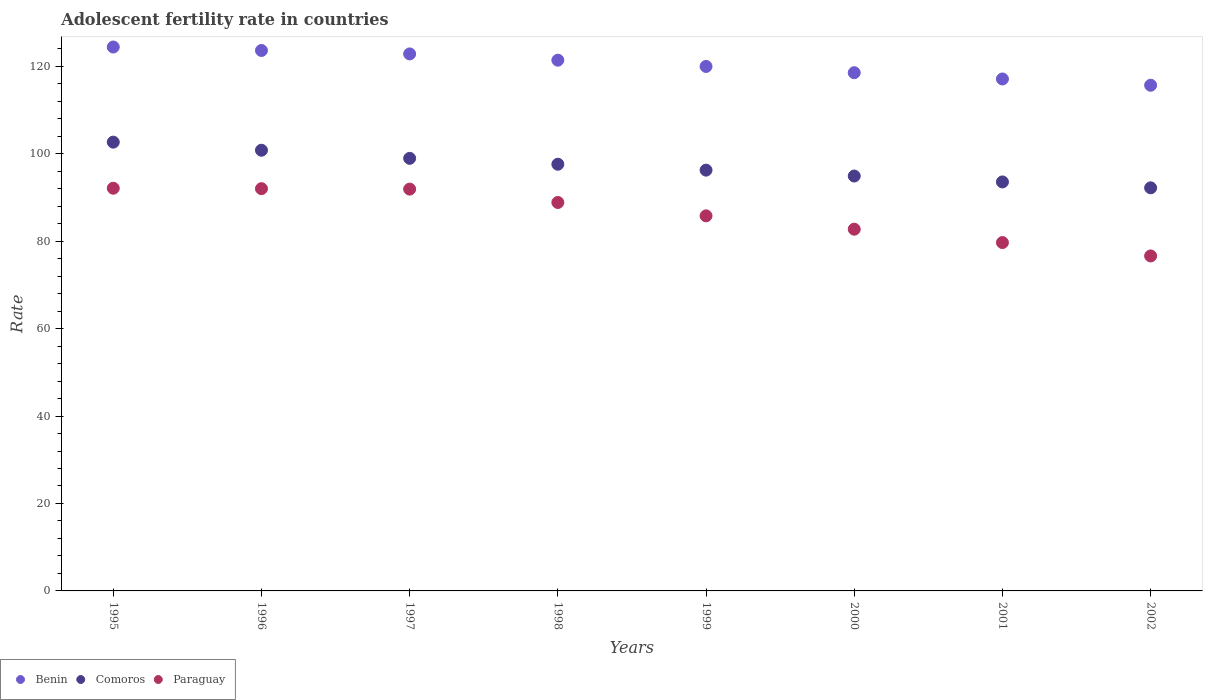How many different coloured dotlines are there?
Provide a short and direct response. 3. Is the number of dotlines equal to the number of legend labels?
Provide a short and direct response. Yes. What is the adolescent fertility rate in Paraguay in 1998?
Keep it short and to the point. 88.85. Across all years, what is the maximum adolescent fertility rate in Paraguay?
Offer a terse response. 92.1. Across all years, what is the minimum adolescent fertility rate in Comoros?
Make the answer very short. 92.19. In which year was the adolescent fertility rate in Benin maximum?
Your answer should be compact. 1995. What is the total adolescent fertility rate in Paraguay in the graph?
Your answer should be compact. 689.67. What is the difference between the adolescent fertility rate in Paraguay in 1999 and that in 2000?
Your answer should be compact. 3.06. What is the difference between the adolescent fertility rate in Paraguay in 1997 and the adolescent fertility rate in Comoros in 1999?
Offer a very short reply. -4.34. What is the average adolescent fertility rate in Comoros per year?
Provide a short and direct response. 97.11. In the year 2001, what is the difference between the adolescent fertility rate in Benin and adolescent fertility rate in Comoros?
Ensure brevity in your answer.  23.55. What is the ratio of the adolescent fertility rate in Paraguay in 1995 to that in 1997?
Ensure brevity in your answer.  1. Is the adolescent fertility rate in Benin in 1995 less than that in 1997?
Provide a succinct answer. No. What is the difference between the highest and the second highest adolescent fertility rate in Benin?
Your response must be concise. 0.79. What is the difference between the highest and the lowest adolescent fertility rate in Comoros?
Your answer should be compact. 10.45. Is the sum of the adolescent fertility rate in Benin in 1996 and 2000 greater than the maximum adolescent fertility rate in Comoros across all years?
Keep it short and to the point. Yes. Is it the case that in every year, the sum of the adolescent fertility rate in Comoros and adolescent fertility rate in Benin  is greater than the adolescent fertility rate in Paraguay?
Give a very brief answer. Yes. Does the adolescent fertility rate in Paraguay monotonically increase over the years?
Your answer should be compact. No. Is the adolescent fertility rate in Comoros strictly less than the adolescent fertility rate in Benin over the years?
Ensure brevity in your answer.  Yes. How many years are there in the graph?
Your response must be concise. 8. What is the difference between two consecutive major ticks on the Y-axis?
Keep it short and to the point. 20. Does the graph contain grids?
Offer a very short reply. No. Where does the legend appear in the graph?
Your response must be concise. Bottom left. How are the legend labels stacked?
Give a very brief answer. Horizontal. What is the title of the graph?
Keep it short and to the point. Adolescent fertility rate in countries. Does "Solomon Islands" appear as one of the legend labels in the graph?
Your response must be concise. No. What is the label or title of the Y-axis?
Provide a succinct answer. Rate. What is the Rate in Benin in 1995?
Your answer should be very brief. 124.4. What is the Rate in Comoros in 1995?
Provide a short and direct response. 102.64. What is the Rate of Paraguay in 1995?
Give a very brief answer. 92.1. What is the Rate of Benin in 1996?
Give a very brief answer. 123.61. What is the Rate of Comoros in 1996?
Keep it short and to the point. 100.79. What is the Rate in Paraguay in 1996?
Provide a succinct answer. 92. What is the Rate of Benin in 1997?
Ensure brevity in your answer.  122.82. What is the Rate in Comoros in 1997?
Your answer should be very brief. 98.94. What is the Rate of Paraguay in 1997?
Your answer should be compact. 91.9. What is the Rate in Benin in 1998?
Your answer should be compact. 121.39. What is the Rate of Comoros in 1998?
Offer a very short reply. 97.59. What is the Rate of Paraguay in 1998?
Your response must be concise. 88.85. What is the Rate of Benin in 1999?
Give a very brief answer. 119.96. What is the Rate in Comoros in 1999?
Your response must be concise. 96.24. What is the Rate in Paraguay in 1999?
Your answer should be very brief. 85.79. What is the Rate of Benin in 2000?
Offer a very short reply. 118.52. What is the Rate in Comoros in 2000?
Your answer should be very brief. 94.89. What is the Rate in Paraguay in 2000?
Your response must be concise. 82.73. What is the Rate in Benin in 2001?
Offer a terse response. 117.09. What is the Rate in Comoros in 2001?
Provide a succinct answer. 93.54. What is the Rate in Paraguay in 2001?
Your response must be concise. 79.68. What is the Rate of Benin in 2002?
Give a very brief answer. 115.66. What is the Rate in Comoros in 2002?
Offer a terse response. 92.19. What is the Rate of Paraguay in 2002?
Your answer should be compact. 76.62. Across all years, what is the maximum Rate in Benin?
Your response must be concise. 124.4. Across all years, what is the maximum Rate of Comoros?
Make the answer very short. 102.64. Across all years, what is the maximum Rate in Paraguay?
Provide a short and direct response. 92.1. Across all years, what is the minimum Rate in Benin?
Give a very brief answer. 115.66. Across all years, what is the minimum Rate of Comoros?
Ensure brevity in your answer.  92.19. Across all years, what is the minimum Rate in Paraguay?
Ensure brevity in your answer.  76.62. What is the total Rate of Benin in the graph?
Your response must be concise. 963.46. What is the total Rate of Comoros in the graph?
Your response must be concise. 776.85. What is the total Rate in Paraguay in the graph?
Make the answer very short. 689.67. What is the difference between the Rate in Benin in 1995 and that in 1996?
Provide a short and direct response. 0.79. What is the difference between the Rate of Comoros in 1995 and that in 1996?
Keep it short and to the point. 1.85. What is the difference between the Rate in Paraguay in 1995 and that in 1996?
Provide a succinct answer. 0.1. What is the difference between the Rate in Benin in 1995 and that in 1997?
Your response must be concise. 1.58. What is the difference between the Rate in Comoros in 1995 and that in 1997?
Your answer should be compact. 3.7. What is the difference between the Rate of Paraguay in 1995 and that in 1997?
Your response must be concise. 0.2. What is the difference between the Rate in Benin in 1995 and that in 1998?
Your response must be concise. 3.01. What is the difference between the Rate of Comoros in 1995 and that in 1998?
Your response must be concise. 5.05. What is the difference between the Rate of Paraguay in 1995 and that in 1998?
Give a very brief answer. 3.26. What is the difference between the Rate of Benin in 1995 and that in 1999?
Your answer should be very brief. 4.44. What is the difference between the Rate in Comoros in 1995 and that in 1999?
Ensure brevity in your answer.  6.4. What is the difference between the Rate in Paraguay in 1995 and that in 1999?
Offer a very short reply. 6.31. What is the difference between the Rate in Benin in 1995 and that in 2000?
Your answer should be very brief. 5.88. What is the difference between the Rate in Comoros in 1995 and that in 2000?
Your answer should be very brief. 7.75. What is the difference between the Rate of Paraguay in 1995 and that in 2000?
Offer a terse response. 9.37. What is the difference between the Rate of Benin in 1995 and that in 2001?
Offer a very short reply. 7.31. What is the difference between the Rate in Comoros in 1995 and that in 2001?
Give a very brief answer. 9.1. What is the difference between the Rate in Paraguay in 1995 and that in 2001?
Ensure brevity in your answer.  12.43. What is the difference between the Rate in Benin in 1995 and that in 2002?
Make the answer very short. 8.74. What is the difference between the Rate in Comoros in 1995 and that in 2002?
Provide a short and direct response. 10.45. What is the difference between the Rate of Paraguay in 1995 and that in 2002?
Offer a very short reply. 15.48. What is the difference between the Rate in Benin in 1996 and that in 1997?
Make the answer very short. 0.79. What is the difference between the Rate of Comoros in 1996 and that in 1997?
Keep it short and to the point. 1.85. What is the difference between the Rate of Paraguay in 1996 and that in 1997?
Make the answer very short. 0.1. What is the difference between the Rate in Benin in 1996 and that in 1998?
Your answer should be very brief. 2.22. What is the difference between the Rate in Comoros in 1996 and that in 1998?
Offer a terse response. 3.2. What is the difference between the Rate of Paraguay in 1996 and that in 1998?
Keep it short and to the point. 3.16. What is the difference between the Rate of Benin in 1996 and that in 1999?
Keep it short and to the point. 3.65. What is the difference between the Rate in Comoros in 1996 and that in 1999?
Your answer should be very brief. 4.55. What is the difference between the Rate in Paraguay in 1996 and that in 1999?
Your answer should be very brief. 6.21. What is the difference between the Rate in Benin in 1996 and that in 2000?
Ensure brevity in your answer.  5.09. What is the difference between the Rate of Comoros in 1996 and that in 2000?
Your response must be concise. 5.9. What is the difference between the Rate in Paraguay in 1996 and that in 2000?
Give a very brief answer. 9.27. What is the difference between the Rate in Benin in 1996 and that in 2001?
Make the answer very short. 6.52. What is the difference between the Rate in Comoros in 1996 and that in 2001?
Offer a terse response. 7.25. What is the difference between the Rate of Paraguay in 1996 and that in 2001?
Offer a terse response. 12.33. What is the difference between the Rate in Benin in 1996 and that in 2002?
Ensure brevity in your answer.  7.95. What is the difference between the Rate of Comoros in 1996 and that in 2002?
Give a very brief answer. 8.6. What is the difference between the Rate of Paraguay in 1996 and that in 2002?
Ensure brevity in your answer.  15.38. What is the difference between the Rate in Benin in 1997 and that in 1998?
Your answer should be very brief. 1.43. What is the difference between the Rate in Comoros in 1997 and that in 1998?
Offer a very short reply. 1.35. What is the difference between the Rate in Paraguay in 1997 and that in 1998?
Ensure brevity in your answer.  3.06. What is the difference between the Rate in Benin in 1997 and that in 1999?
Make the answer very short. 2.87. What is the difference between the Rate in Comoros in 1997 and that in 1999?
Give a very brief answer. 2.7. What is the difference between the Rate of Paraguay in 1997 and that in 1999?
Your answer should be compact. 6.11. What is the difference between the Rate in Benin in 1997 and that in 2000?
Keep it short and to the point. 4.3. What is the difference between the Rate of Comoros in 1997 and that in 2000?
Your response must be concise. 4.05. What is the difference between the Rate of Paraguay in 1997 and that in 2000?
Your answer should be compact. 9.17. What is the difference between the Rate of Benin in 1997 and that in 2001?
Ensure brevity in your answer.  5.73. What is the difference between the Rate in Comoros in 1997 and that in 2001?
Offer a very short reply. 5.4. What is the difference between the Rate in Paraguay in 1997 and that in 2001?
Your answer should be compact. 12.23. What is the difference between the Rate of Benin in 1997 and that in 2002?
Your answer should be compact. 7.16. What is the difference between the Rate in Comoros in 1997 and that in 2002?
Make the answer very short. 6.75. What is the difference between the Rate in Paraguay in 1997 and that in 2002?
Offer a very short reply. 15.28. What is the difference between the Rate in Benin in 1998 and that in 1999?
Give a very brief answer. 1.43. What is the difference between the Rate of Comoros in 1998 and that in 1999?
Provide a short and direct response. 1.35. What is the difference between the Rate in Paraguay in 1998 and that in 1999?
Make the answer very short. 3.06. What is the difference between the Rate of Benin in 1998 and that in 2000?
Give a very brief answer. 2.87. What is the difference between the Rate of Comoros in 1998 and that in 2000?
Offer a very short reply. 2.7. What is the difference between the Rate of Paraguay in 1998 and that in 2000?
Keep it short and to the point. 6.11. What is the difference between the Rate of Benin in 1998 and that in 2001?
Your response must be concise. 4.3. What is the difference between the Rate in Comoros in 1998 and that in 2001?
Provide a short and direct response. 4.05. What is the difference between the Rate of Paraguay in 1998 and that in 2001?
Make the answer very short. 9.17. What is the difference between the Rate of Benin in 1998 and that in 2002?
Offer a very short reply. 5.73. What is the difference between the Rate of Comoros in 1998 and that in 2002?
Ensure brevity in your answer.  5.4. What is the difference between the Rate in Paraguay in 1998 and that in 2002?
Make the answer very short. 12.23. What is the difference between the Rate of Benin in 1999 and that in 2000?
Your response must be concise. 1.43. What is the difference between the Rate of Comoros in 1999 and that in 2000?
Your response must be concise. 1.35. What is the difference between the Rate of Paraguay in 1999 and that in 2000?
Provide a succinct answer. 3.06. What is the difference between the Rate of Benin in 1999 and that in 2001?
Offer a very short reply. 2.87. What is the difference between the Rate in Comoros in 1999 and that in 2001?
Offer a very short reply. 2.7. What is the difference between the Rate in Paraguay in 1999 and that in 2001?
Keep it short and to the point. 6.11. What is the difference between the Rate in Benin in 1999 and that in 2002?
Offer a terse response. 4.3. What is the difference between the Rate in Comoros in 1999 and that in 2002?
Give a very brief answer. 4.05. What is the difference between the Rate in Paraguay in 1999 and that in 2002?
Your answer should be compact. 9.17. What is the difference between the Rate of Benin in 2000 and that in 2001?
Provide a short and direct response. 1.43. What is the difference between the Rate in Comoros in 2000 and that in 2001?
Give a very brief answer. 1.35. What is the difference between the Rate in Paraguay in 2000 and that in 2001?
Give a very brief answer. 3.06. What is the difference between the Rate of Benin in 2000 and that in 2002?
Provide a succinct answer. 2.87. What is the difference between the Rate of Comoros in 2000 and that in 2002?
Provide a succinct answer. 2.7. What is the difference between the Rate of Paraguay in 2000 and that in 2002?
Provide a succinct answer. 6.11. What is the difference between the Rate in Benin in 2001 and that in 2002?
Your response must be concise. 1.43. What is the difference between the Rate in Comoros in 2001 and that in 2002?
Offer a terse response. 1.35. What is the difference between the Rate of Paraguay in 2001 and that in 2002?
Offer a terse response. 3.06. What is the difference between the Rate in Benin in 1995 and the Rate in Comoros in 1996?
Provide a short and direct response. 23.61. What is the difference between the Rate of Benin in 1995 and the Rate of Paraguay in 1996?
Keep it short and to the point. 32.4. What is the difference between the Rate of Comoros in 1995 and the Rate of Paraguay in 1996?
Offer a very short reply. 10.64. What is the difference between the Rate of Benin in 1995 and the Rate of Comoros in 1997?
Give a very brief answer. 25.46. What is the difference between the Rate of Benin in 1995 and the Rate of Paraguay in 1997?
Offer a very short reply. 32.5. What is the difference between the Rate in Comoros in 1995 and the Rate in Paraguay in 1997?
Offer a very short reply. 10.74. What is the difference between the Rate of Benin in 1995 and the Rate of Comoros in 1998?
Your answer should be compact. 26.81. What is the difference between the Rate in Benin in 1995 and the Rate in Paraguay in 1998?
Your response must be concise. 35.55. What is the difference between the Rate in Comoros in 1995 and the Rate in Paraguay in 1998?
Ensure brevity in your answer.  13.8. What is the difference between the Rate in Benin in 1995 and the Rate in Comoros in 1999?
Your answer should be very brief. 28.16. What is the difference between the Rate of Benin in 1995 and the Rate of Paraguay in 1999?
Provide a succinct answer. 38.61. What is the difference between the Rate of Comoros in 1995 and the Rate of Paraguay in 1999?
Give a very brief answer. 16.86. What is the difference between the Rate of Benin in 1995 and the Rate of Comoros in 2000?
Provide a succinct answer. 29.51. What is the difference between the Rate of Benin in 1995 and the Rate of Paraguay in 2000?
Your answer should be very brief. 41.67. What is the difference between the Rate in Comoros in 1995 and the Rate in Paraguay in 2000?
Make the answer very short. 19.91. What is the difference between the Rate in Benin in 1995 and the Rate in Comoros in 2001?
Keep it short and to the point. 30.86. What is the difference between the Rate of Benin in 1995 and the Rate of Paraguay in 2001?
Your answer should be compact. 44.72. What is the difference between the Rate in Comoros in 1995 and the Rate in Paraguay in 2001?
Ensure brevity in your answer.  22.97. What is the difference between the Rate of Benin in 1995 and the Rate of Comoros in 2002?
Offer a very short reply. 32.21. What is the difference between the Rate in Benin in 1995 and the Rate in Paraguay in 2002?
Offer a very short reply. 47.78. What is the difference between the Rate in Comoros in 1995 and the Rate in Paraguay in 2002?
Offer a terse response. 26.03. What is the difference between the Rate of Benin in 1996 and the Rate of Comoros in 1997?
Provide a succinct answer. 24.67. What is the difference between the Rate in Benin in 1996 and the Rate in Paraguay in 1997?
Provide a short and direct response. 31.71. What is the difference between the Rate of Comoros in 1996 and the Rate of Paraguay in 1997?
Give a very brief answer. 8.89. What is the difference between the Rate of Benin in 1996 and the Rate of Comoros in 1998?
Provide a succinct answer. 26.02. What is the difference between the Rate of Benin in 1996 and the Rate of Paraguay in 1998?
Make the answer very short. 34.77. What is the difference between the Rate of Comoros in 1996 and the Rate of Paraguay in 1998?
Provide a short and direct response. 11.95. What is the difference between the Rate in Benin in 1996 and the Rate in Comoros in 1999?
Make the answer very short. 27.37. What is the difference between the Rate of Benin in 1996 and the Rate of Paraguay in 1999?
Ensure brevity in your answer.  37.82. What is the difference between the Rate of Comoros in 1996 and the Rate of Paraguay in 1999?
Your answer should be very brief. 15. What is the difference between the Rate of Benin in 1996 and the Rate of Comoros in 2000?
Ensure brevity in your answer.  28.72. What is the difference between the Rate in Benin in 1996 and the Rate in Paraguay in 2000?
Your answer should be very brief. 40.88. What is the difference between the Rate in Comoros in 1996 and the Rate in Paraguay in 2000?
Make the answer very short. 18.06. What is the difference between the Rate of Benin in 1996 and the Rate of Comoros in 2001?
Your answer should be very brief. 30.07. What is the difference between the Rate of Benin in 1996 and the Rate of Paraguay in 2001?
Your response must be concise. 43.94. What is the difference between the Rate of Comoros in 1996 and the Rate of Paraguay in 2001?
Make the answer very short. 21.12. What is the difference between the Rate in Benin in 1996 and the Rate in Comoros in 2002?
Your answer should be compact. 31.42. What is the difference between the Rate in Benin in 1996 and the Rate in Paraguay in 2002?
Your answer should be very brief. 46.99. What is the difference between the Rate in Comoros in 1996 and the Rate in Paraguay in 2002?
Keep it short and to the point. 24.17. What is the difference between the Rate in Benin in 1997 and the Rate in Comoros in 1998?
Your response must be concise. 25.23. What is the difference between the Rate of Benin in 1997 and the Rate of Paraguay in 1998?
Offer a very short reply. 33.98. What is the difference between the Rate of Comoros in 1997 and the Rate of Paraguay in 1998?
Offer a very short reply. 10.1. What is the difference between the Rate of Benin in 1997 and the Rate of Comoros in 1999?
Ensure brevity in your answer.  26.58. What is the difference between the Rate of Benin in 1997 and the Rate of Paraguay in 1999?
Your answer should be compact. 37.03. What is the difference between the Rate in Comoros in 1997 and the Rate in Paraguay in 1999?
Give a very brief answer. 13.15. What is the difference between the Rate of Benin in 1997 and the Rate of Comoros in 2000?
Provide a succinct answer. 27.93. What is the difference between the Rate of Benin in 1997 and the Rate of Paraguay in 2000?
Your answer should be very brief. 40.09. What is the difference between the Rate in Comoros in 1997 and the Rate in Paraguay in 2000?
Your answer should be compact. 16.21. What is the difference between the Rate of Benin in 1997 and the Rate of Comoros in 2001?
Your answer should be very brief. 29.28. What is the difference between the Rate in Benin in 1997 and the Rate in Paraguay in 2001?
Your response must be concise. 43.15. What is the difference between the Rate in Comoros in 1997 and the Rate in Paraguay in 2001?
Your answer should be very brief. 19.27. What is the difference between the Rate of Benin in 1997 and the Rate of Comoros in 2002?
Your response must be concise. 30.63. What is the difference between the Rate of Benin in 1997 and the Rate of Paraguay in 2002?
Ensure brevity in your answer.  46.2. What is the difference between the Rate in Comoros in 1997 and the Rate in Paraguay in 2002?
Your answer should be very brief. 22.32. What is the difference between the Rate of Benin in 1998 and the Rate of Comoros in 1999?
Keep it short and to the point. 25.15. What is the difference between the Rate in Benin in 1998 and the Rate in Paraguay in 1999?
Make the answer very short. 35.6. What is the difference between the Rate of Comoros in 1998 and the Rate of Paraguay in 1999?
Keep it short and to the point. 11.8. What is the difference between the Rate in Benin in 1998 and the Rate in Comoros in 2000?
Ensure brevity in your answer.  26.5. What is the difference between the Rate in Benin in 1998 and the Rate in Paraguay in 2000?
Keep it short and to the point. 38.66. What is the difference between the Rate in Comoros in 1998 and the Rate in Paraguay in 2000?
Ensure brevity in your answer.  14.86. What is the difference between the Rate in Benin in 1998 and the Rate in Comoros in 2001?
Give a very brief answer. 27.85. What is the difference between the Rate in Benin in 1998 and the Rate in Paraguay in 2001?
Keep it short and to the point. 41.71. What is the difference between the Rate of Comoros in 1998 and the Rate of Paraguay in 2001?
Your answer should be very brief. 17.92. What is the difference between the Rate in Benin in 1998 and the Rate in Comoros in 2002?
Offer a very short reply. 29.2. What is the difference between the Rate of Benin in 1998 and the Rate of Paraguay in 2002?
Make the answer very short. 44.77. What is the difference between the Rate of Comoros in 1998 and the Rate of Paraguay in 2002?
Offer a terse response. 20.97. What is the difference between the Rate in Benin in 1999 and the Rate in Comoros in 2000?
Your response must be concise. 25.06. What is the difference between the Rate in Benin in 1999 and the Rate in Paraguay in 2000?
Offer a terse response. 37.23. What is the difference between the Rate of Comoros in 1999 and the Rate of Paraguay in 2000?
Your response must be concise. 13.51. What is the difference between the Rate in Benin in 1999 and the Rate in Comoros in 2001?
Your answer should be compact. 26.41. What is the difference between the Rate of Benin in 1999 and the Rate of Paraguay in 2001?
Your answer should be very brief. 40.28. What is the difference between the Rate in Comoros in 1999 and the Rate in Paraguay in 2001?
Provide a short and direct response. 16.57. What is the difference between the Rate of Benin in 1999 and the Rate of Comoros in 2002?
Keep it short and to the point. 27.76. What is the difference between the Rate in Benin in 1999 and the Rate in Paraguay in 2002?
Ensure brevity in your answer.  43.34. What is the difference between the Rate of Comoros in 1999 and the Rate of Paraguay in 2002?
Provide a short and direct response. 19.62. What is the difference between the Rate of Benin in 2000 and the Rate of Comoros in 2001?
Your answer should be compact. 24.98. What is the difference between the Rate in Benin in 2000 and the Rate in Paraguay in 2001?
Provide a short and direct response. 38.85. What is the difference between the Rate in Comoros in 2000 and the Rate in Paraguay in 2001?
Keep it short and to the point. 15.22. What is the difference between the Rate in Benin in 2000 and the Rate in Comoros in 2002?
Ensure brevity in your answer.  26.33. What is the difference between the Rate in Benin in 2000 and the Rate in Paraguay in 2002?
Provide a succinct answer. 41.91. What is the difference between the Rate in Comoros in 2000 and the Rate in Paraguay in 2002?
Give a very brief answer. 18.27. What is the difference between the Rate of Benin in 2001 and the Rate of Comoros in 2002?
Ensure brevity in your answer.  24.9. What is the difference between the Rate in Benin in 2001 and the Rate in Paraguay in 2002?
Provide a short and direct response. 40.47. What is the difference between the Rate of Comoros in 2001 and the Rate of Paraguay in 2002?
Your response must be concise. 16.93. What is the average Rate in Benin per year?
Ensure brevity in your answer.  120.43. What is the average Rate of Comoros per year?
Make the answer very short. 97.11. What is the average Rate in Paraguay per year?
Provide a succinct answer. 86.21. In the year 1995, what is the difference between the Rate of Benin and Rate of Comoros?
Offer a terse response. 21.76. In the year 1995, what is the difference between the Rate of Benin and Rate of Paraguay?
Your answer should be compact. 32.3. In the year 1995, what is the difference between the Rate of Comoros and Rate of Paraguay?
Provide a succinct answer. 10.54. In the year 1996, what is the difference between the Rate in Benin and Rate in Comoros?
Offer a terse response. 22.82. In the year 1996, what is the difference between the Rate in Benin and Rate in Paraguay?
Ensure brevity in your answer.  31.61. In the year 1996, what is the difference between the Rate of Comoros and Rate of Paraguay?
Your answer should be very brief. 8.79. In the year 1997, what is the difference between the Rate of Benin and Rate of Comoros?
Your answer should be very brief. 23.88. In the year 1997, what is the difference between the Rate in Benin and Rate in Paraguay?
Keep it short and to the point. 30.92. In the year 1997, what is the difference between the Rate in Comoros and Rate in Paraguay?
Provide a succinct answer. 7.04. In the year 1998, what is the difference between the Rate of Benin and Rate of Comoros?
Make the answer very short. 23.8. In the year 1998, what is the difference between the Rate of Benin and Rate of Paraguay?
Your response must be concise. 32.54. In the year 1998, what is the difference between the Rate of Comoros and Rate of Paraguay?
Offer a terse response. 8.75. In the year 1999, what is the difference between the Rate in Benin and Rate in Comoros?
Offer a very short reply. 23.71. In the year 1999, what is the difference between the Rate of Benin and Rate of Paraguay?
Give a very brief answer. 34.17. In the year 1999, what is the difference between the Rate in Comoros and Rate in Paraguay?
Give a very brief answer. 10.45. In the year 2000, what is the difference between the Rate of Benin and Rate of Comoros?
Offer a very short reply. 23.63. In the year 2000, what is the difference between the Rate of Benin and Rate of Paraguay?
Keep it short and to the point. 35.79. In the year 2000, what is the difference between the Rate in Comoros and Rate in Paraguay?
Make the answer very short. 12.16. In the year 2001, what is the difference between the Rate in Benin and Rate in Comoros?
Keep it short and to the point. 23.55. In the year 2001, what is the difference between the Rate in Benin and Rate in Paraguay?
Provide a short and direct response. 37.42. In the year 2001, what is the difference between the Rate of Comoros and Rate of Paraguay?
Give a very brief answer. 13.87. In the year 2002, what is the difference between the Rate in Benin and Rate in Comoros?
Ensure brevity in your answer.  23.46. In the year 2002, what is the difference between the Rate in Benin and Rate in Paraguay?
Offer a terse response. 39.04. In the year 2002, what is the difference between the Rate in Comoros and Rate in Paraguay?
Give a very brief answer. 15.58. What is the ratio of the Rate in Benin in 1995 to that in 1996?
Give a very brief answer. 1.01. What is the ratio of the Rate of Comoros in 1995 to that in 1996?
Make the answer very short. 1.02. What is the ratio of the Rate of Paraguay in 1995 to that in 1996?
Your response must be concise. 1. What is the ratio of the Rate in Benin in 1995 to that in 1997?
Provide a short and direct response. 1.01. What is the ratio of the Rate of Comoros in 1995 to that in 1997?
Ensure brevity in your answer.  1.04. What is the ratio of the Rate in Benin in 1995 to that in 1998?
Keep it short and to the point. 1.02. What is the ratio of the Rate in Comoros in 1995 to that in 1998?
Your response must be concise. 1.05. What is the ratio of the Rate in Paraguay in 1995 to that in 1998?
Keep it short and to the point. 1.04. What is the ratio of the Rate of Comoros in 1995 to that in 1999?
Give a very brief answer. 1.07. What is the ratio of the Rate of Paraguay in 1995 to that in 1999?
Provide a short and direct response. 1.07. What is the ratio of the Rate in Benin in 1995 to that in 2000?
Offer a very short reply. 1.05. What is the ratio of the Rate in Comoros in 1995 to that in 2000?
Provide a short and direct response. 1.08. What is the ratio of the Rate in Paraguay in 1995 to that in 2000?
Provide a succinct answer. 1.11. What is the ratio of the Rate of Benin in 1995 to that in 2001?
Offer a very short reply. 1.06. What is the ratio of the Rate of Comoros in 1995 to that in 2001?
Offer a terse response. 1.1. What is the ratio of the Rate of Paraguay in 1995 to that in 2001?
Keep it short and to the point. 1.16. What is the ratio of the Rate in Benin in 1995 to that in 2002?
Your answer should be compact. 1.08. What is the ratio of the Rate in Comoros in 1995 to that in 2002?
Offer a terse response. 1.11. What is the ratio of the Rate of Paraguay in 1995 to that in 2002?
Offer a very short reply. 1.2. What is the ratio of the Rate in Benin in 1996 to that in 1997?
Make the answer very short. 1.01. What is the ratio of the Rate of Comoros in 1996 to that in 1997?
Your answer should be compact. 1.02. What is the ratio of the Rate of Benin in 1996 to that in 1998?
Your answer should be compact. 1.02. What is the ratio of the Rate in Comoros in 1996 to that in 1998?
Keep it short and to the point. 1.03. What is the ratio of the Rate in Paraguay in 1996 to that in 1998?
Your response must be concise. 1.04. What is the ratio of the Rate in Benin in 1996 to that in 1999?
Your response must be concise. 1.03. What is the ratio of the Rate of Comoros in 1996 to that in 1999?
Your response must be concise. 1.05. What is the ratio of the Rate in Paraguay in 1996 to that in 1999?
Offer a terse response. 1.07. What is the ratio of the Rate of Benin in 1996 to that in 2000?
Give a very brief answer. 1.04. What is the ratio of the Rate in Comoros in 1996 to that in 2000?
Provide a short and direct response. 1.06. What is the ratio of the Rate of Paraguay in 1996 to that in 2000?
Keep it short and to the point. 1.11. What is the ratio of the Rate of Benin in 1996 to that in 2001?
Provide a succinct answer. 1.06. What is the ratio of the Rate of Comoros in 1996 to that in 2001?
Ensure brevity in your answer.  1.08. What is the ratio of the Rate in Paraguay in 1996 to that in 2001?
Provide a short and direct response. 1.15. What is the ratio of the Rate of Benin in 1996 to that in 2002?
Offer a terse response. 1.07. What is the ratio of the Rate in Comoros in 1996 to that in 2002?
Offer a terse response. 1.09. What is the ratio of the Rate of Paraguay in 1996 to that in 2002?
Offer a terse response. 1.2. What is the ratio of the Rate in Benin in 1997 to that in 1998?
Keep it short and to the point. 1.01. What is the ratio of the Rate of Comoros in 1997 to that in 1998?
Your answer should be very brief. 1.01. What is the ratio of the Rate in Paraguay in 1997 to that in 1998?
Your answer should be very brief. 1.03. What is the ratio of the Rate in Benin in 1997 to that in 1999?
Make the answer very short. 1.02. What is the ratio of the Rate of Comoros in 1997 to that in 1999?
Offer a very short reply. 1.03. What is the ratio of the Rate in Paraguay in 1997 to that in 1999?
Keep it short and to the point. 1.07. What is the ratio of the Rate in Benin in 1997 to that in 2000?
Provide a short and direct response. 1.04. What is the ratio of the Rate in Comoros in 1997 to that in 2000?
Provide a short and direct response. 1.04. What is the ratio of the Rate in Paraguay in 1997 to that in 2000?
Provide a succinct answer. 1.11. What is the ratio of the Rate of Benin in 1997 to that in 2001?
Give a very brief answer. 1.05. What is the ratio of the Rate in Comoros in 1997 to that in 2001?
Offer a very short reply. 1.06. What is the ratio of the Rate in Paraguay in 1997 to that in 2001?
Your response must be concise. 1.15. What is the ratio of the Rate in Benin in 1997 to that in 2002?
Offer a terse response. 1.06. What is the ratio of the Rate in Comoros in 1997 to that in 2002?
Offer a terse response. 1.07. What is the ratio of the Rate of Paraguay in 1997 to that in 2002?
Offer a terse response. 1.2. What is the ratio of the Rate of Benin in 1998 to that in 1999?
Make the answer very short. 1.01. What is the ratio of the Rate of Comoros in 1998 to that in 1999?
Provide a succinct answer. 1.01. What is the ratio of the Rate of Paraguay in 1998 to that in 1999?
Provide a succinct answer. 1.04. What is the ratio of the Rate of Benin in 1998 to that in 2000?
Give a very brief answer. 1.02. What is the ratio of the Rate of Comoros in 1998 to that in 2000?
Your answer should be very brief. 1.03. What is the ratio of the Rate of Paraguay in 1998 to that in 2000?
Make the answer very short. 1.07. What is the ratio of the Rate in Benin in 1998 to that in 2001?
Provide a succinct answer. 1.04. What is the ratio of the Rate in Comoros in 1998 to that in 2001?
Keep it short and to the point. 1.04. What is the ratio of the Rate of Paraguay in 1998 to that in 2001?
Provide a succinct answer. 1.12. What is the ratio of the Rate in Benin in 1998 to that in 2002?
Keep it short and to the point. 1.05. What is the ratio of the Rate in Comoros in 1998 to that in 2002?
Keep it short and to the point. 1.06. What is the ratio of the Rate of Paraguay in 1998 to that in 2002?
Provide a succinct answer. 1.16. What is the ratio of the Rate of Benin in 1999 to that in 2000?
Offer a very short reply. 1.01. What is the ratio of the Rate of Comoros in 1999 to that in 2000?
Give a very brief answer. 1.01. What is the ratio of the Rate in Paraguay in 1999 to that in 2000?
Offer a terse response. 1.04. What is the ratio of the Rate in Benin in 1999 to that in 2001?
Your answer should be compact. 1.02. What is the ratio of the Rate in Comoros in 1999 to that in 2001?
Give a very brief answer. 1.03. What is the ratio of the Rate in Paraguay in 1999 to that in 2001?
Your response must be concise. 1.08. What is the ratio of the Rate of Benin in 1999 to that in 2002?
Provide a succinct answer. 1.04. What is the ratio of the Rate of Comoros in 1999 to that in 2002?
Your answer should be very brief. 1.04. What is the ratio of the Rate in Paraguay in 1999 to that in 2002?
Provide a short and direct response. 1.12. What is the ratio of the Rate in Benin in 2000 to that in 2001?
Your response must be concise. 1.01. What is the ratio of the Rate of Comoros in 2000 to that in 2001?
Your response must be concise. 1.01. What is the ratio of the Rate in Paraguay in 2000 to that in 2001?
Your answer should be very brief. 1.04. What is the ratio of the Rate in Benin in 2000 to that in 2002?
Make the answer very short. 1.02. What is the ratio of the Rate in Comoros in 2000 to that in 2002?
Offer a very short reply. 1.03. What is the ratio of the Rate in Paraguay in 2000 to that in 2002?
Provide a succinct answer. 1.08. What is the ratio of the Rate of Benin in 2001 to that in 2002?
Keep it short and to the point. 1.01. What is the ratio of the Rate of Comoros in 2001 to that in 2002?
Make the answer very short. 1.01. What is the ratio of the Rate of Paraguay in 2001 to that in 2002?
Give a very brief answer. 1.04. What is the difference between the highest and the second highest Rate of Benin?
Ensure brevity in your answer.  0.79. What is the difference between the highest and the second highest Rate in Comoros?
Make the answer very short. 1.85. What is the difference between the highest and the second highest Rate in Paraguay?
Ensure brevity in your answer.  0.1. What is the difference between the highest and the lowest Rate of Benin?
Provide a succinct answer. 8.74. What is the difference between the highest and the lowest Rate in Comoros?
Your answer should be very brief. 10.45. What is the difference between the highest and the lowest Rate of Paraguay?
Your response must be concise. 15.48. 